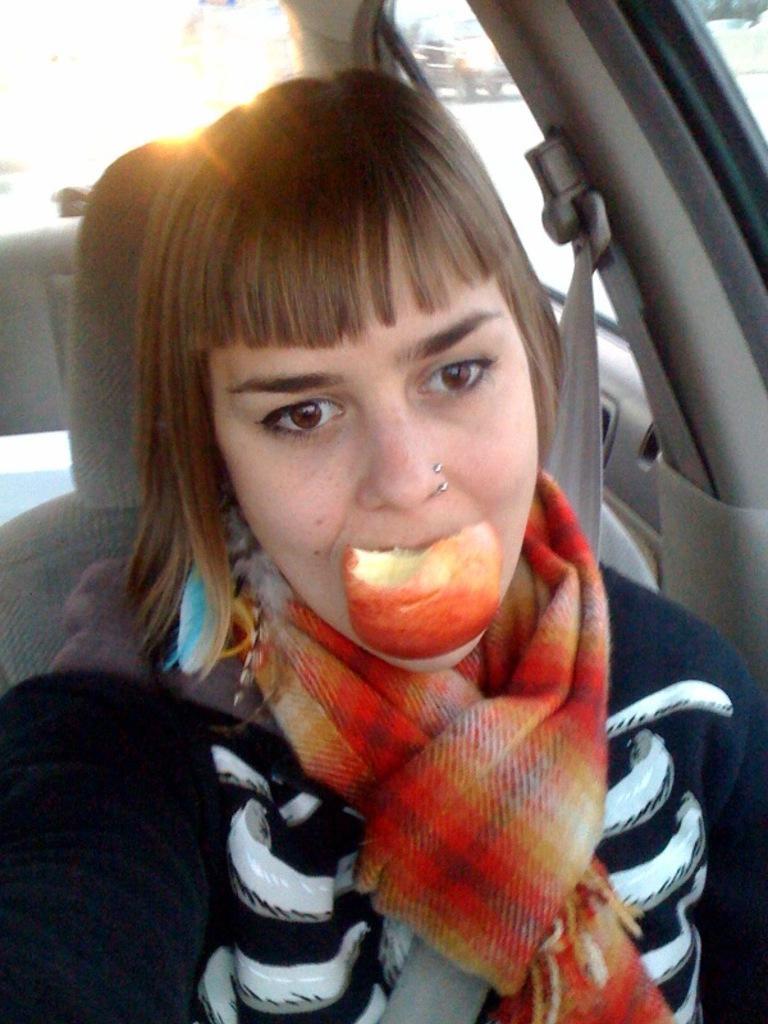In one or two sentences, can you explain what this image depicts? A woman is eating apple, this is car. 